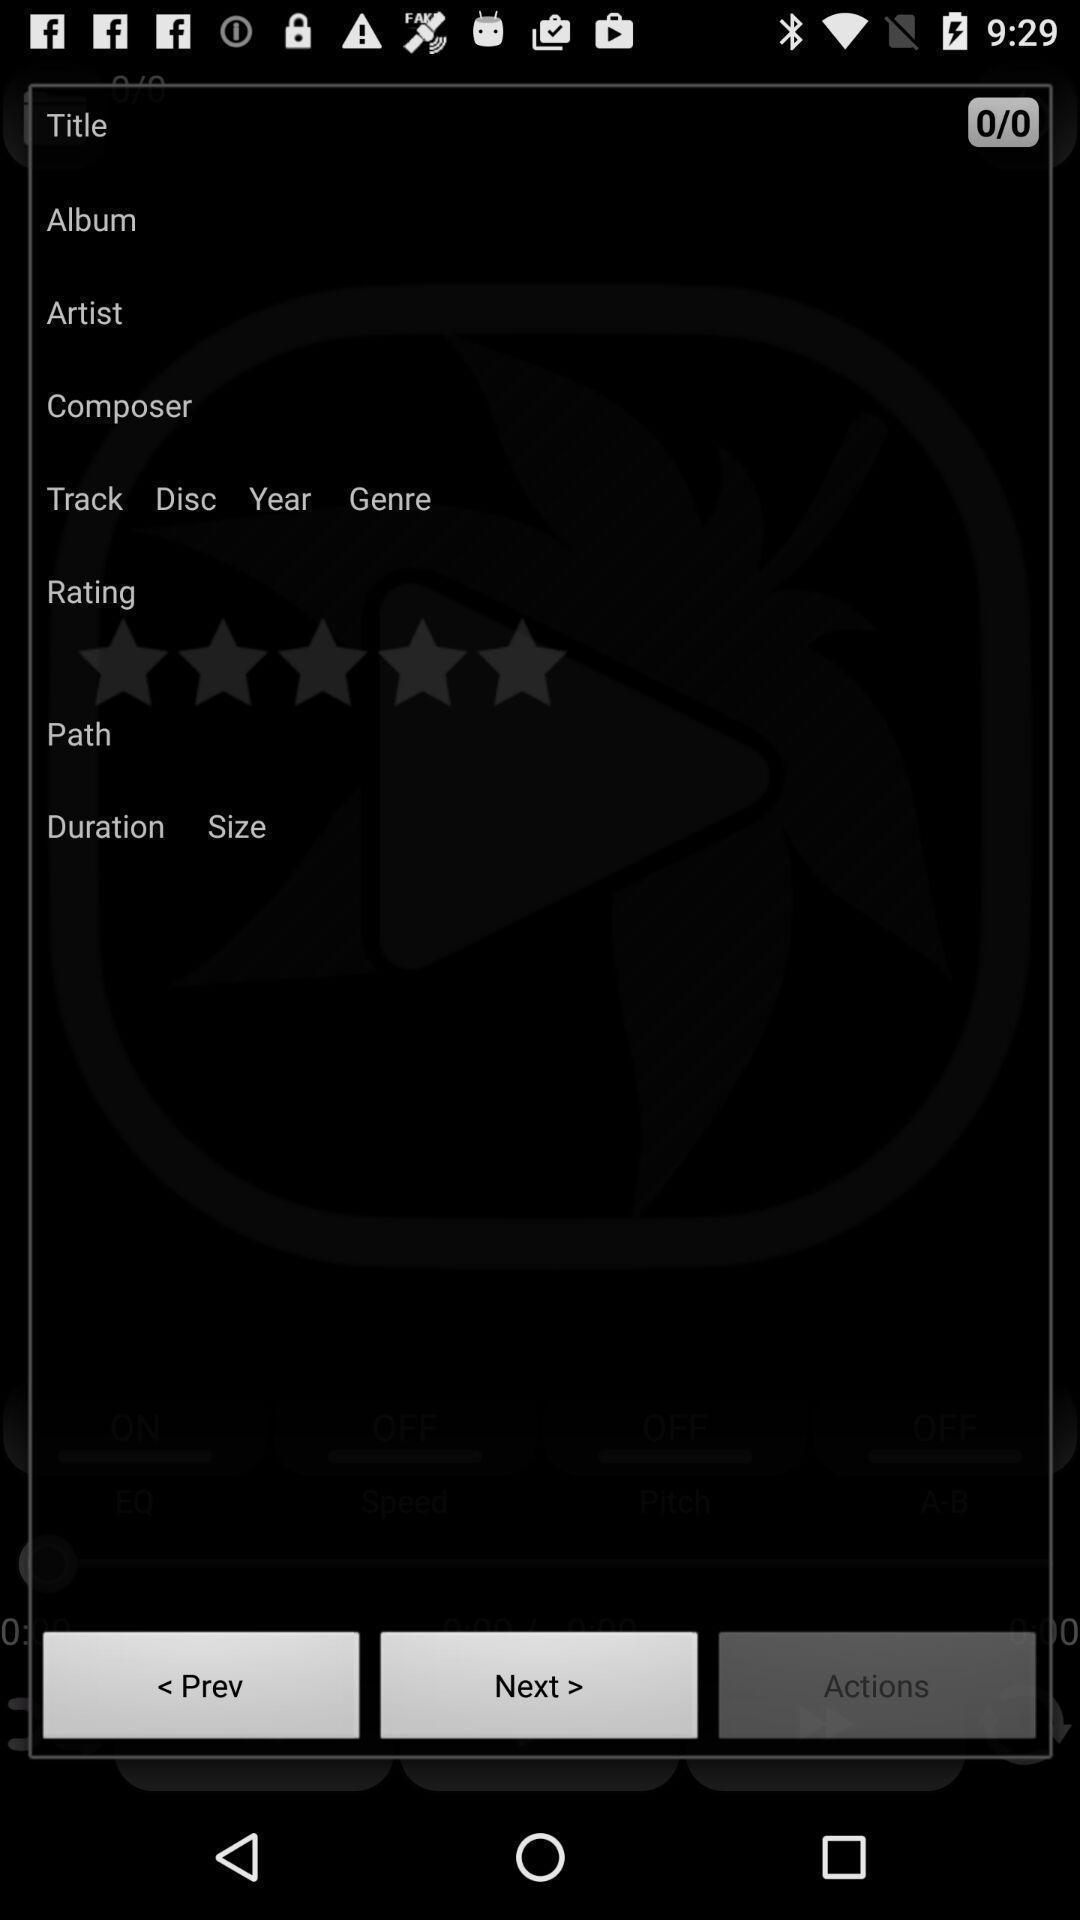Describe this image in words. Screen displaying multiple options in a feedback form. 